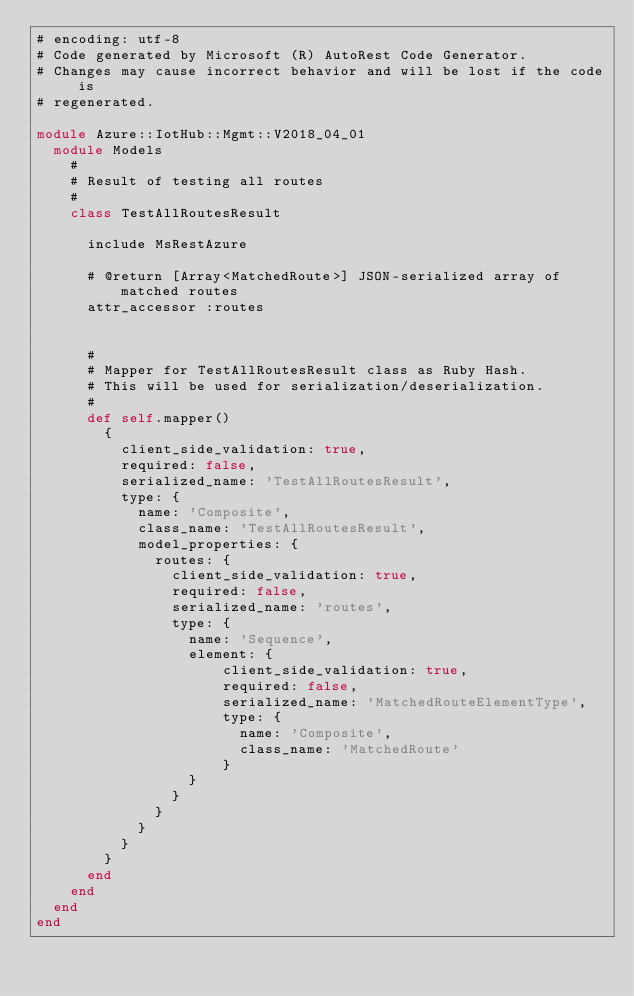<code> <loc_0><loc_0><loc_500><loc_500><_Ruby_># encoding: utf-8
# Code generated by Microsoft (R) AutoRest Code Generator.
# Changes may cause incorrect behavior and will be lost if the code is
# regenerated.

module Azure::IotHub::Mgmt::V2018_04_01
  module Models
    #
    # Result of testing all routes
    #
    class TestAllRoutesResult

      include MsRestAzure

      # @return [Array<MatchedRoute>] JSON-serialized array of matched routes
      attr_accessor :routes


      #
      # Mapper for TestAllRoutesResult class as Ruby Hash.
      # This will be used for serialization/deserialization.
      #
      def self.mapper()
        {
          client_side_validation: true,
          required: false,
          serialized_name: 'TestAllRoutesResult',
          type: {
            name: 'Composite',
            class_name: 'TestAllRoutesResult',
            model_properties: {
              routes: {
                client_side_validation: true,
                required: false,
                serialized_name: 'routes',
                type: {
                  name: 'Sequence',
                  element: {
                      client_side_validation: true,
                      required: false,
                      serialized_name: 'MatchedRouteElementType',
                      type: {
                        name: 'Composite',
                        class_name: 'MatchedRoute'
                      }
                  }
                }
              }
            }
          }
        }
      end
    end
  end
end
</code> 